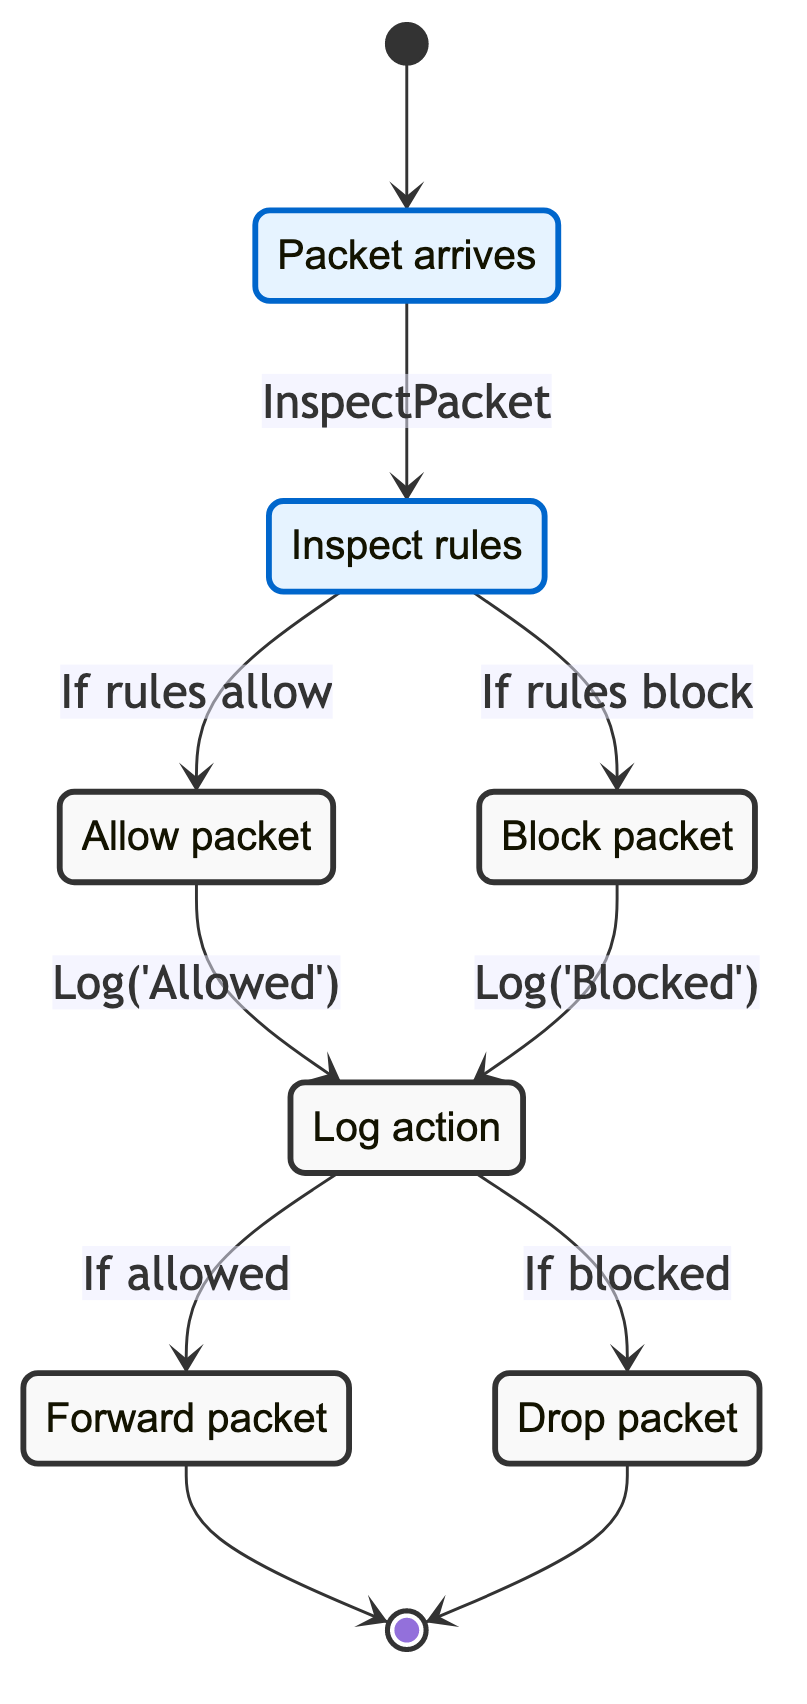¿Cuántos estados hay en el diagrama? El diagrama muestra un total de siete estados. Estos son: IncomingPacket, CheckFirewallRules, PacketAllowed, PacketBlocked, LogAction, ForwardPacket, y DropPacket. Cada uno de estos representa un momento o acción específica en el proceso de enrutamiento de paquetes.
Answer: Siete ¿Cuál es la acción que se realiza al entrar en el estado CheckFirewallRules? La acción que se realiza al entrar en el estado CheckFirewallRules es "InspectPacket". Esto se indica como la acción que conecta el estado IncomingPacket con CheckFirewallRules, sugiriendo que cada vez que un paquete llega, se inspecciona en este estado.
Answer: InspectPacket ¿Qué sucede si el paquete es bloqueado? Si el paquete es bloqueado, se registra la acción en el estado LogAction, y luego se transita al estado DropPacket, donde el paquete se descarta. Esto se puede seguir en el flujo del diagrama.
Answer: Se descarta ¿Cuál es el estado siguiente después de LogAction si el paquete es permitido? Si el paquete es permitido, el siguiente estado es ForwardPacket. Esta transición ocurre bajo la condición de que la acción de registro fue para un paquete permitido en el estado LogAction.
Answer: ForwardPacket ¿Qué se registra en el estado LogAction si el paquete es permitido? En el estado LogAction, si el paquete es permitido, se registra el mensaje 'Allowed'. Este registro es importante para el seguimiento y la auditoría de las acciones del firewall.
Answer: Allowed ¿Cuántas transiciones se producen después de que el paquete es bloqueado? Después de que el paquete es bloqueado, hay una sola transición que se produce, que es a LogAction, donde se registra que el paquete ha sido bloqueado. Desde LogAction, se transita al estado DropPacket.
Answer: Dos ¿Qué ocurre en el estado PacketAllowed? En el estado PacketAllowed, se registra el mensaje 'Allowed' y luego se pasa al estado LogAction. Esta es una parte crucial del flujo, ya que representa el tratamiento de los paquetes permitidos.
Answer: LogAction ¿Qué condición lleva a un paquete a ser bloqueado? Un paquete es bloqueado si las reglas del firewall especifican que el paquete debe ser bloqueado. Esta condición se evalúa en el estado CheckFirewallRules antes de decidir el estado final del paquete.
Answer: Si reglas bloquean ¿Cuál es la última acción en el proceso si un paquete es permitido? La última acción en el proceso si un paquete es permitido es ForwardPacket. Esto indica que el paquete ha pasado todas las verificaciones y se va a enviar a su destino final.
Answer: ForwardPacket 